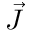<formula> <loc_0><loc_0><loc_500><loc_500>\vec { J }</formula> 